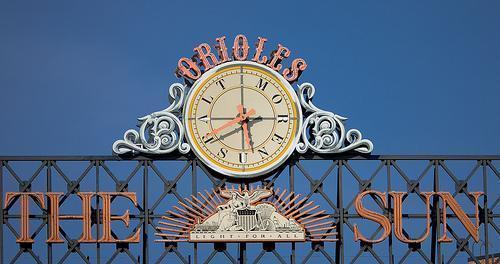How many clock on the steel?
Give a very brief answer. 1. 